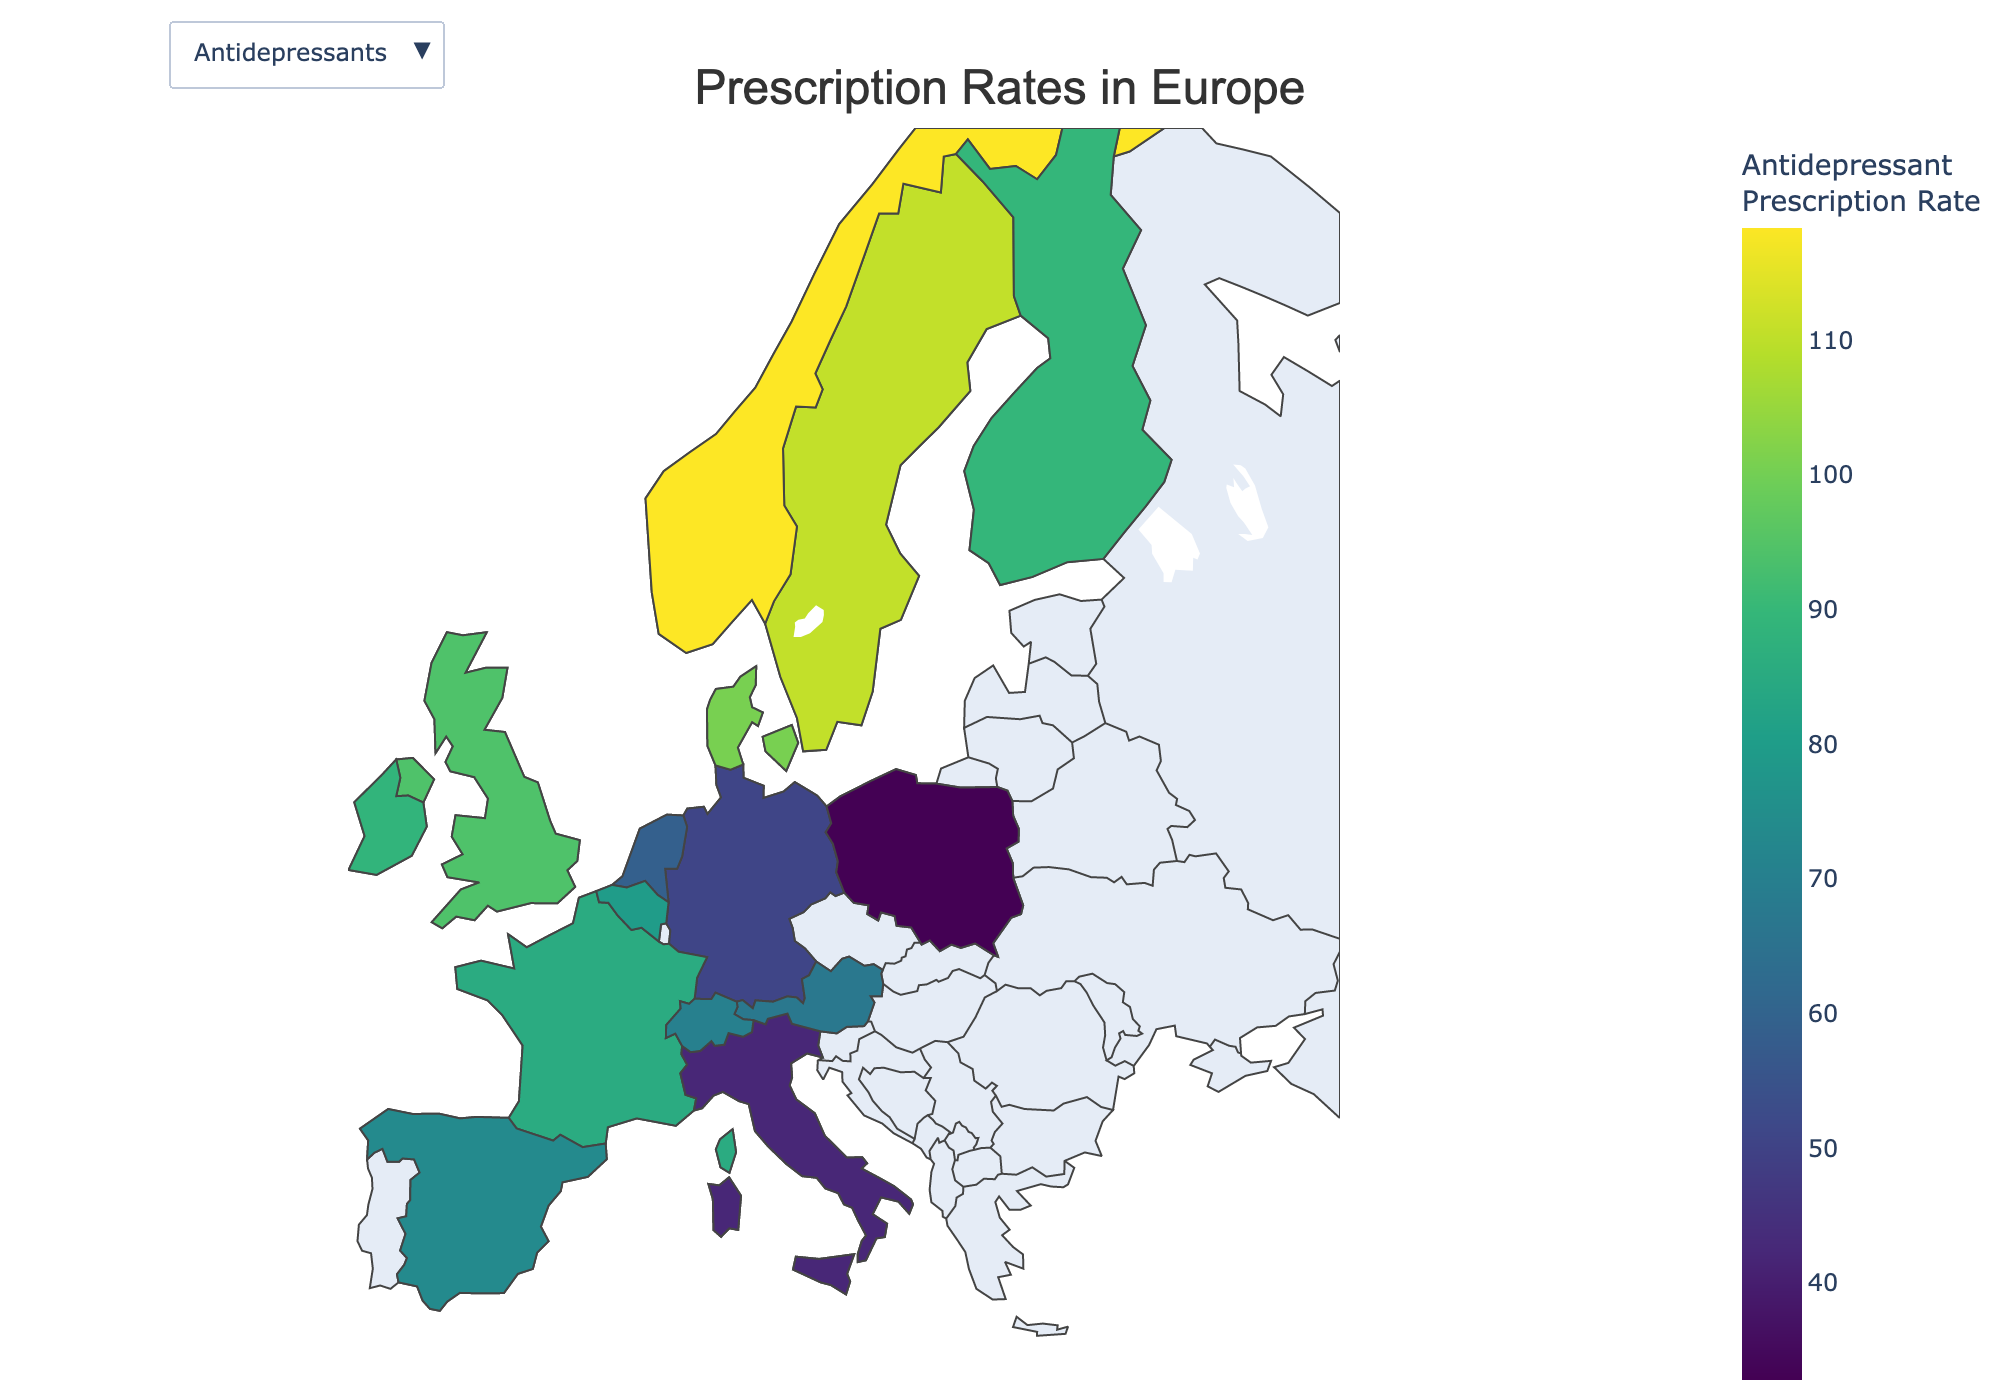What is the title of the figure? The title of a figure is typically displayed at the top of the plot and provides a summary of what the figure is about. In this case, it states: "Prescription Rates in Europe".
Answer: Prescription Rates in Europe Which country has the highest antidepressant prescription rate? To find the country with the highest antidepressant prescription rate, look at the color intensity on the map or refer to the color bar legend. The country with the darkest color in the 'Antidepressants' view has the highest rate.
Answer: Norway Which country has the lowest anti-anxiety medication prescription rate? Switch to the 'Anti-Anxiety Medications' view and identify the country with the lightest color. This corresponds to the lowest prescription rate according to the color bar legend.
Answer: Poland What is the approximate difference in antidepressant prescription rates between Sweden and Germany? First, find Sweden and Germany's rates from the legend or map color. Then, subtract Germany's rate from Sweden's rate: 110.5 (Sweden) - 50.7 (Germany).
Answer: 59.8 How do the prescription rates for antidepressants in the UK compare to those in France? Locate the UK and France on the map under 'Antidepressants' view, then compare their colors or exact rates from the legend. The UK has a rate of 94.2 and France has a rate of 85.3.
Answer: Higher in the UK What is common about the prescription rates for anti-anxiety medications in Denmark and Sweden? Switch to the 'Anti-Anxiety Medications' view and observe the colors of Denmark and Sweden. Both countries have similar shades, indicating close prescription rates. Verify with the exact values: Denmark (52.3) and Sweden (58.2).
Answer: Both are similar How does the anti-anxiety medication prescription rate in Italy compare to that in Spain? Switch to the 'Anti-Anxiety Medications' view, locate Italy and Spain on the map, and refer to the color intensity or exact values: Italy (38.5) and Spain (61.9).
Answer: Lower in Italy What is the combined prescription rate of antidepressants for Netherlands and Austria? Sum the antidepressant prescription rates of the Netherlands and Austria by checking their values from the map or legend: 58.9 (Netherlands) + 67.2 (Austria).
Answer: 126.1 Which two countries have anti-anxiety medication prescription rates closest to each other? In the 'Anti-Anxiety Medications' view, observe that Belgium and Ireland have similar colors/shades. Verify by checking their exact values: Belgium (65.3) and Ireland (72.4).
Answer: Belgium and Ireland Which Nordic country has the highest prescription rate for anti-anxiety medications? Among the Nordic countries (Norway, Sweden, Denmark, Finland), find the highest value in the 'Anti-Anxiety Medications' view. Norway has 61.5, Sweden 58.2, Denmark 52.3, Finland 50.7.
Answer: Norway 